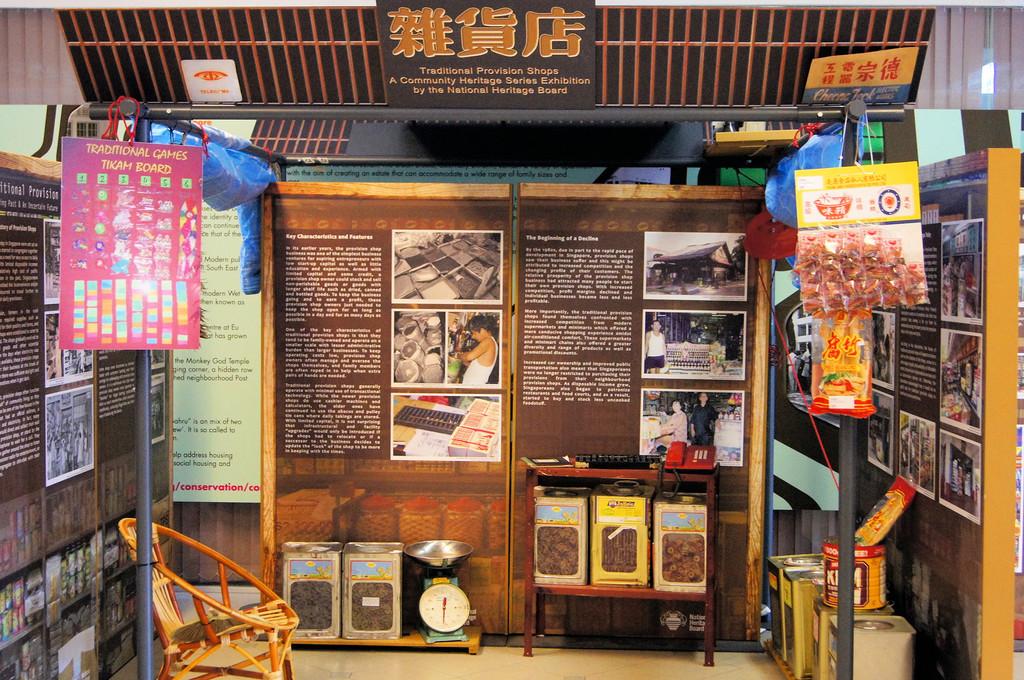Is the sign to the left for traditional games?
Your answer should be compact. Yes. 